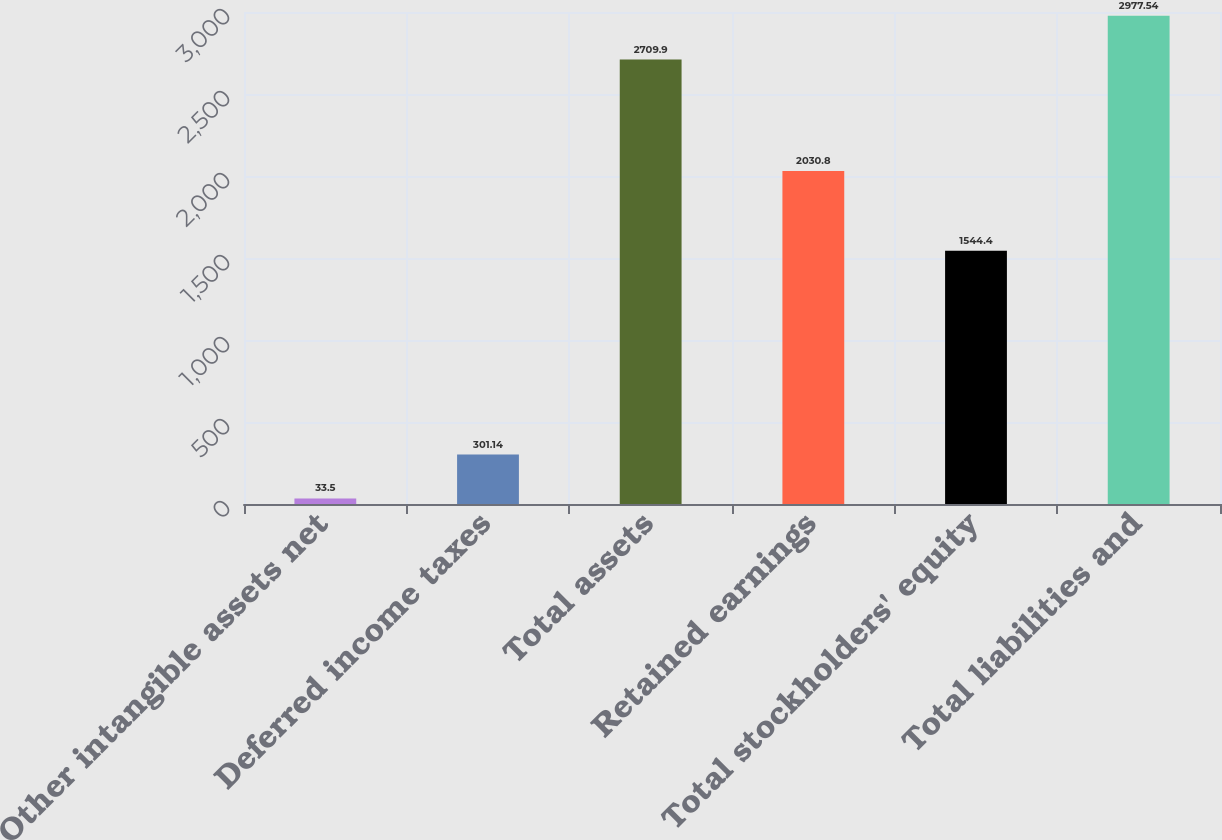Convert chart to OTSL. <chart><loc_0><loc_0><loc_500><loc_500><bar_chart><fcel>Other intangible assets net<fcel>Deferred income taxes<fcel>Total assets<fcel>Retained earnings<fcel>Total stockholders' equity<fcel>Total liabilities and<nl><fcel>33.5<fcel>301.14<fcel>2709.9<fcel>2030.8<fcel>1544.4<fcel>2977.54<nl></chart> 